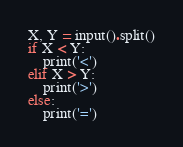Convert code to text. <code><loc_0><loc_0><loc_500><loc_500><_Python_>X, Y = input().split()
if X < Y:
    print('<')
elif X > Y:
    print('>')
else:
    print('=')</code> 